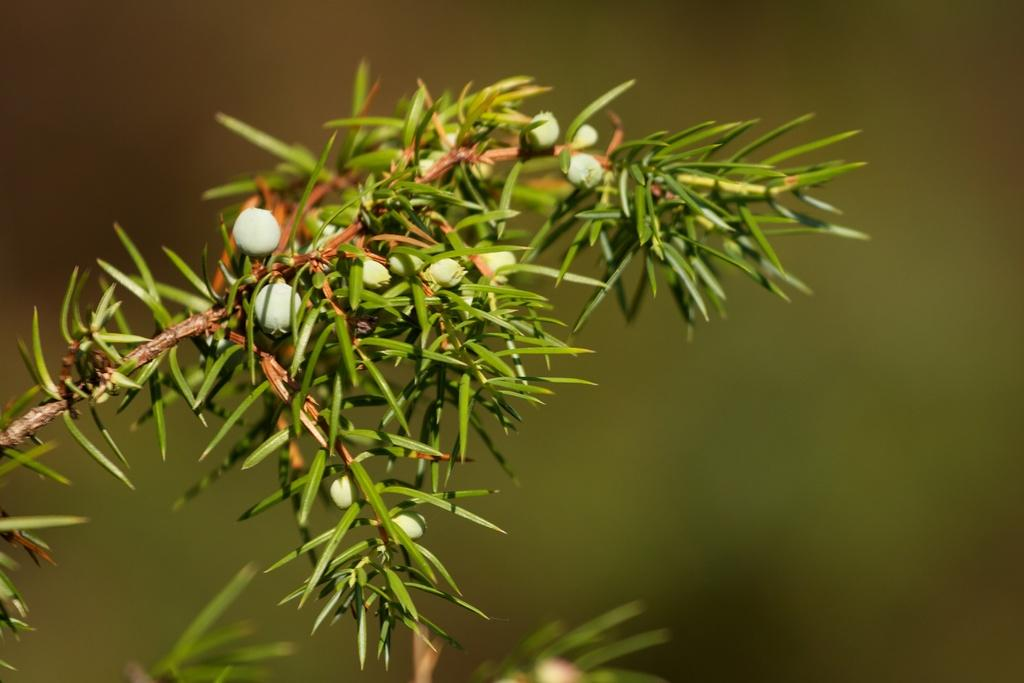What is the main subject of the image? There is a plant in the image. What specific feature can be observed on the plant? The plant has white buds of a flower. Can you describe the background of the image? The background is green and blurred. How many toads are sitting on the trucks in the image? There are no toads or trucks present in the image; it features a plant with white buds of a flower against a green and blurred background. 